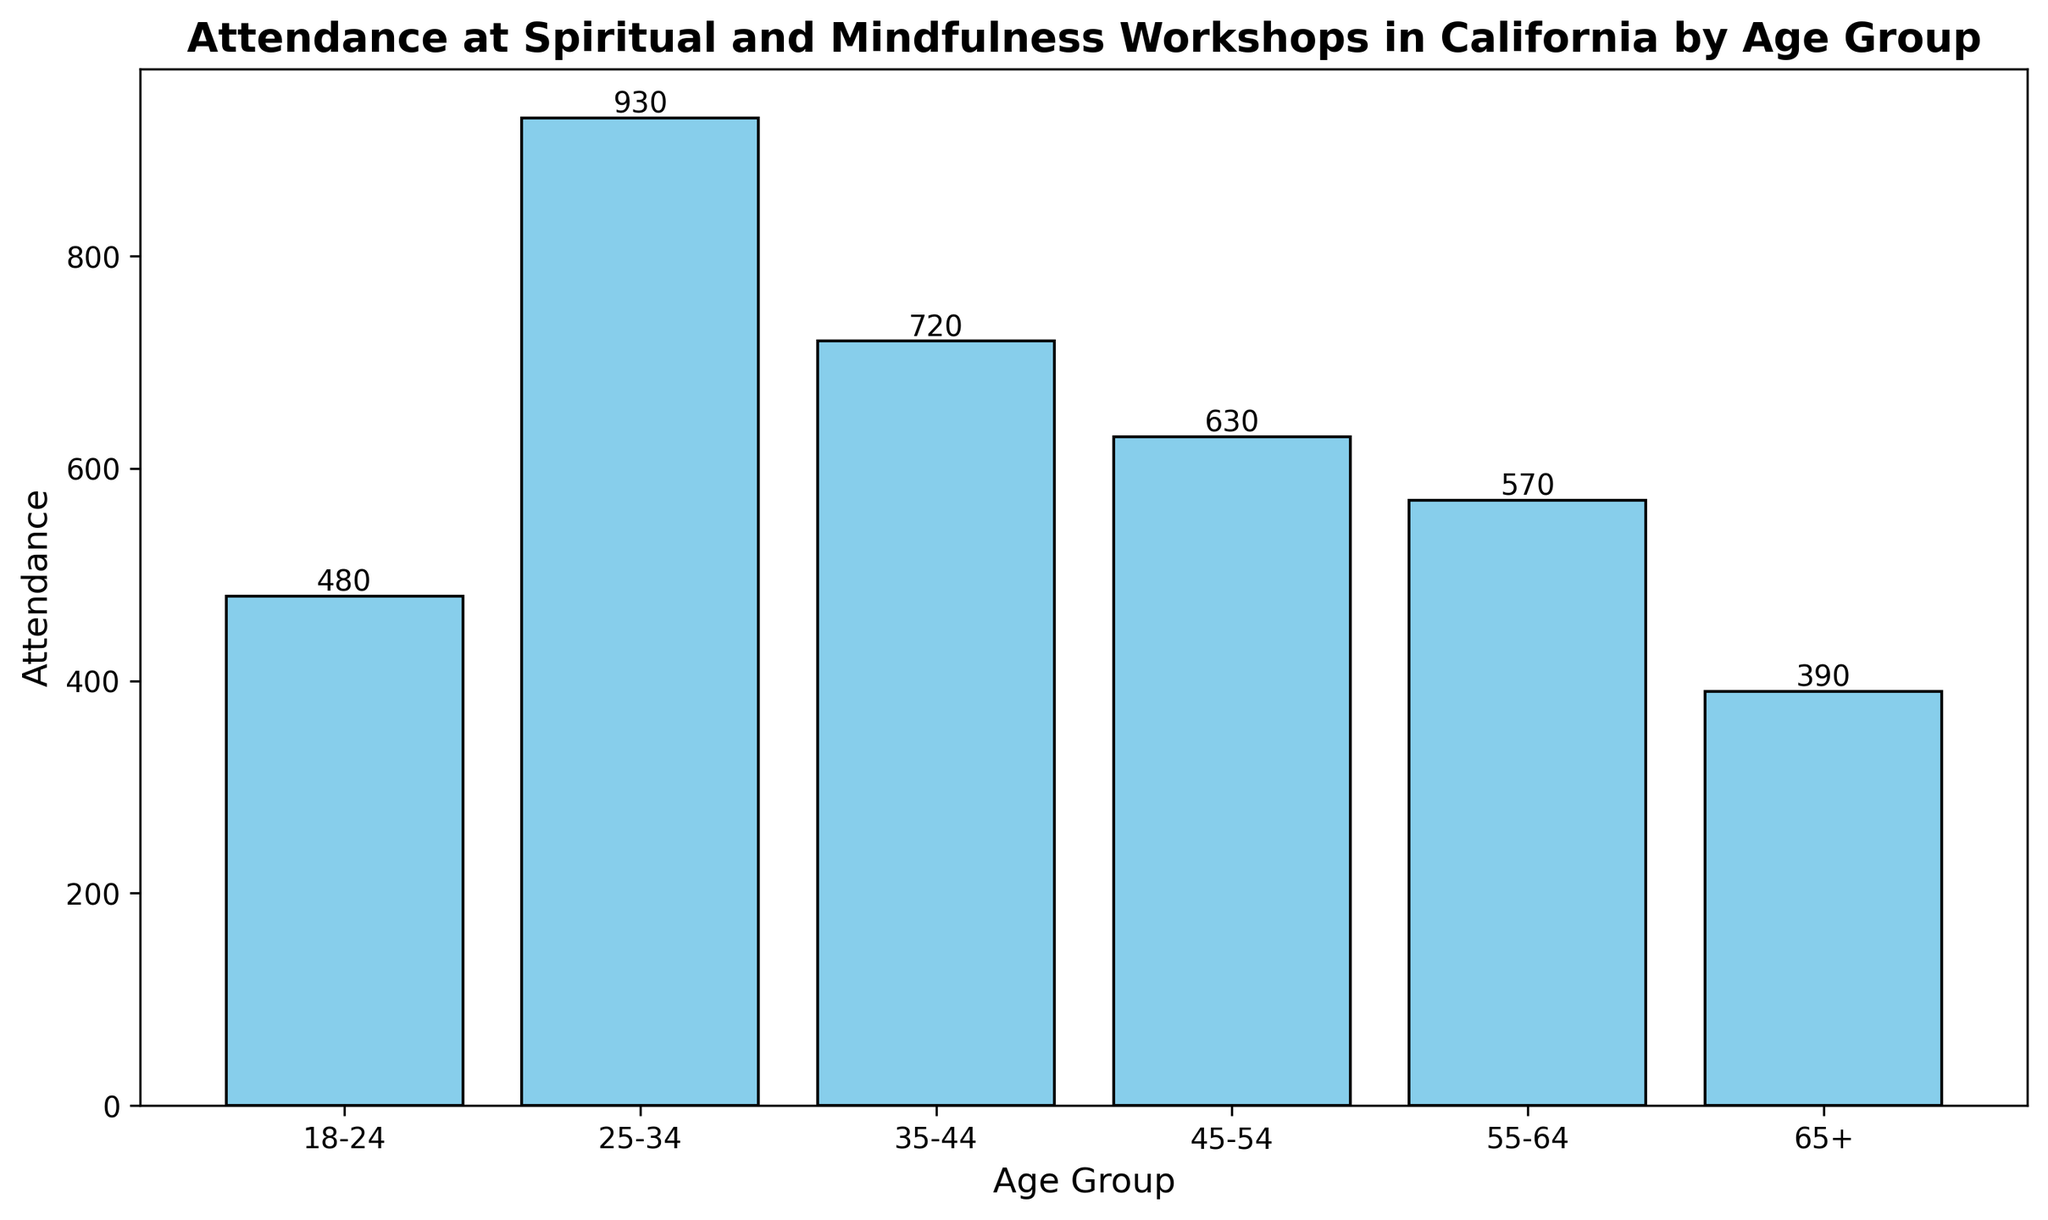What is the age group with the highest attendance? To find the age group with the highest attendance, we look at the bars in the chart and identify the tallest one. The tallest bar corresponds to the age group 25-34.
Answer: 25-34 How does attendance for age group 35-44 compare to that of age group 55-64? We compare the heights of the bars for age groups 35-44 and 55-64. The bar for 35-44 is taller than that for 55-64. Numerically, attendance for 35-44 is 720 while for 55-64 it is 570.
Answer: Attendance for 35-44 is higher than for 55-64 What is the total attendance for age groups 18-24 and 25-34 combined? We sum the attendance values for age groups 18-24 (480) and 25-34 (930). The combined total is 480 + 930 = 1410.
Answer: 1410 What is the difference in attendance between the age group 45-54 and age group 65+? We subtract the attendance of age group 65+ (390) from the attendance of age group 45-54 (630). The difference is 630 - 390 = 240.
Answer: 240 Which age group has the lowest attendance? To find the age group with the lowest attendance, we look for the shortest bar in the chart. The shortest bar corresponds to the age group 65+.
Answer: 65+ What is the average attendance across all age groups? We sum the attendance across all age groups and then divide by the number of age groups. The sum is 480 + 930 + 720 + 630 + 570 + 390 = 3720. There are 6 age groups, so the average is 3720 / 6 = 620.
Answer: 620 How much higher is the attendance for age group 25-34 compared to age group 18-24? We subtract the attendance of age group 18-24 (480) from that of age group 25-34 (930). The difference is 930 - 480 = 450.
Answer: 450 What is the combined attendance for age groups 35-44, 45-54, and 55-64? We sum the attendance values for age groups 35-44 (720), 45-54 (630), and 55-64 (570). The combined total is 720 + 630 + 570 = 1920.
Answer: 1920 Which age group has an attendance closest to 600? We identify the age group with attendance closest to 600. Age groups and their attendance: 18-24 (480), 25-34 (930), 35-44 (720), 45-54 (630), 55-64 (570), 65+ (390). The age group 45-54 with attendance of 630 is closest to 600.
Answer: 45-54 What is the ratio of attendance between the age groups 18-24 and 65+? We divide the attendance of age group 18-24 (480) by the attendance of age group 65+ (390). The ratio is 480 / 390 ≈ 1.23.
Answer: 1.23 